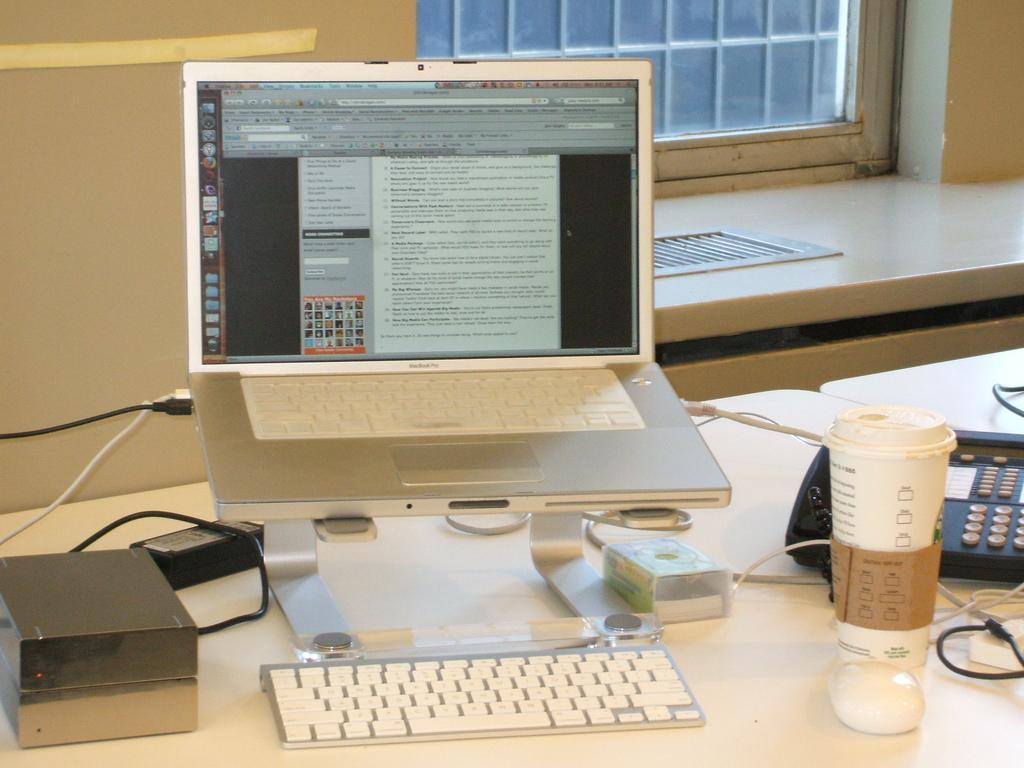Could you give a brief overview of what you see in this image? This image consists of a laptop which is kept on the table. There is a keyboard on the table, glass, landline phone, there are some wires, adapter on the table. In the background there is a window and wall. 